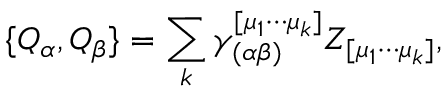<formula> <loc_0><loc_0><loc_500><loc_500>\{ Q _ { \alpha } , Q _ { \beta } \} = \sum _ { k } \gamma _ { ( \alpha \beta ) } ^ { [ \mu _ { 1 } \cdots \mu _ { k } ] } Z _ { [ \mu _ { 1 } \cdots \mu _ { k } ] } ,</formula> 